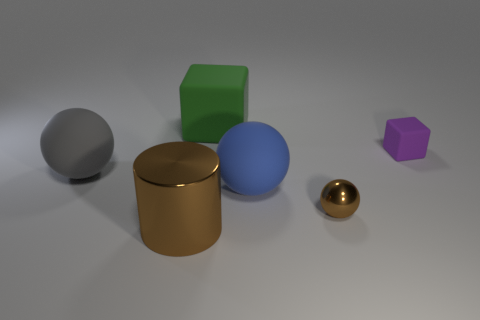Add 3 tiny brown objects. How many objects exist? 9 Subtract all blocks. How many objects are left? 4 Add 2 large purple matte balls. How many large purple matte balls exist? 2 Subtract 0 red spheres. How many objects are left? 6 Subtract all blue objects. Subtract all tiny balls. How many objects are left? 4 Add 6 small purple rubber things. How many small purple rubber things are left? 7 